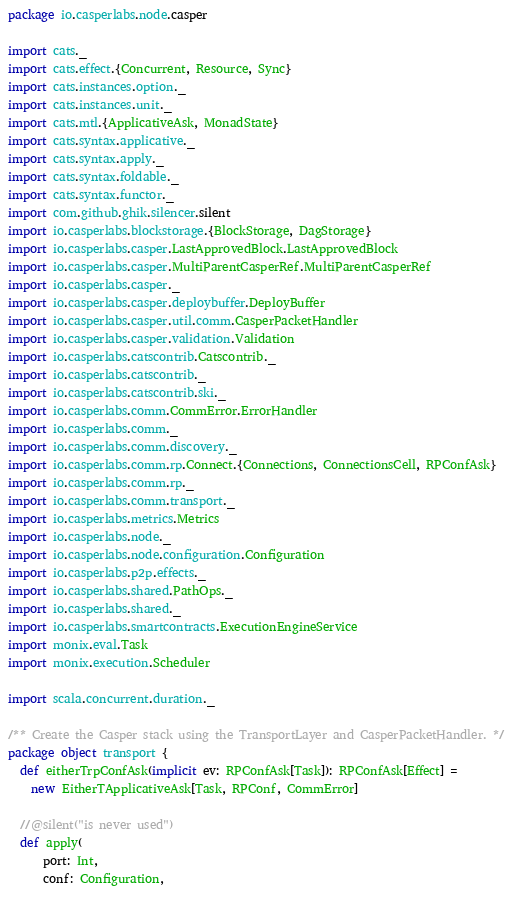Convert code to text. <code><loc_0><loc_0><loc_500><loc_500><_Scala_>package io.casperlabs.node.casper

import cats._
import cats.effect.{Concurrent, Resource, Sync}
import cats.instances.option._
import cats.instances.unit._
import cats.mtl.{ApplicativeAsk, MonadState}
import cats.syntax.applicative._
import cats.syntax.apply._
import cats.syntax.foldable._
import cats.syntax.functor._
import com.github.ghik.silencer.silent
import io.casperlabs.blockstorage.{BlockStorage, DagStorage}
import io.casperlabs.casper.LastApprovedBlock.LastApprovedBlock
import io.casperlabs.casper.MultiParentCasperRef.MultiParentCasperRef
import io.casperlabs.casper._
import io.casperlabs.casper.deploybuffer.DeployBuffer
import io.casperlabs.casper.util.comm.CasperPacketHandler
import io.casperlabs.casper.validation.Validation
import io.casperlabs.catscontrib.Catscontrib._
import io.casperlabs.catscontrib._
import io.casperlabs.catscontrib.ski._
import io.casperlabs.comm.CommError.ErrorHandler
import io.casperlabs.comm._
import io.casperlabs.comm.discovery._
import io.casperlabs.comm.rp.Connect.{Connections, ConnectionsCell, RPConfAsk}
import io.casperlabs.comm.rp._
import io.casperlabs.comm.transport._
import io.casperlabs.metrics.Metrics
import io.casperlabs.node._
import io.casperlabs.node.configuration.Configuration
import io.casperlabs.p2p.effects._
import io.casperlabs.shared.PathOps._
import io.casperlabs.shared._
import io.casperlabs.smartcontracts.ExecutionEngineService
import monix.eval.Task
import monix.execution.Scheduler

import scala.concurrent.duration._

/** Create the Casper stack using the TransportLayer and CasperPacketHandler. */
package object transport {
  def eitherTrpConfAsk(implicit ev: RPConfAsk[Task]): RPConfAsk[Effect] =
    new EitherTApplicativeAsk[Task, RPConf, CommError]

  //@silent("is never used")
  def apply(
      port: Int,
      conf: Configuration,</code> 